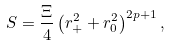<formula> <loc_0><loc_0><loc_500><loc_500>S = \frac { \Xi } { 4 } \left ( r _ { + } ^ { 2 } + r _ { 0 } ^ { 2 } \right ) ^ { 2 p + 1 } ,</formula> 